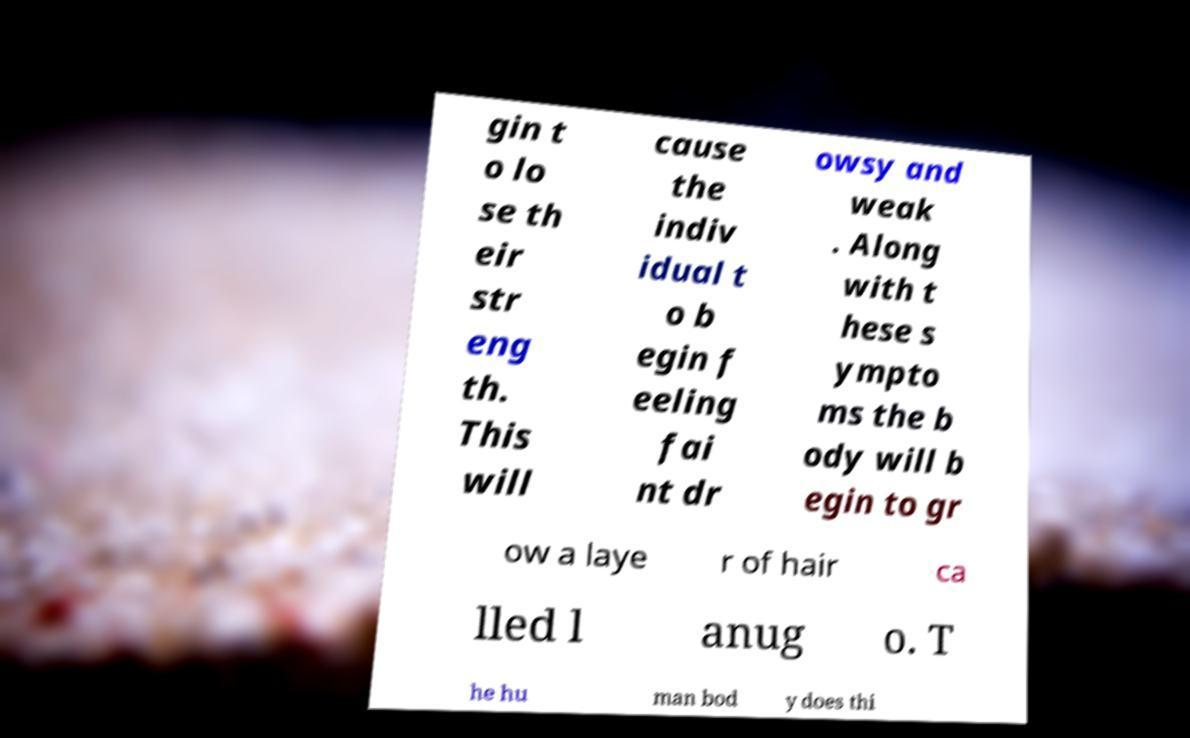Can you read and provide the text displayed in the image?This photo seems to have some interesting text. Can you extract and type it out for me? gin t o lo se th eir str eng th. This will cause the indiv idual t o b egin f eeling fai nt dr owsy and weak . Along with t hese s ympto ms the b ody will b egin to gr ow a laye r of hair ca lled l anug o. T he hu man bod y does thi 